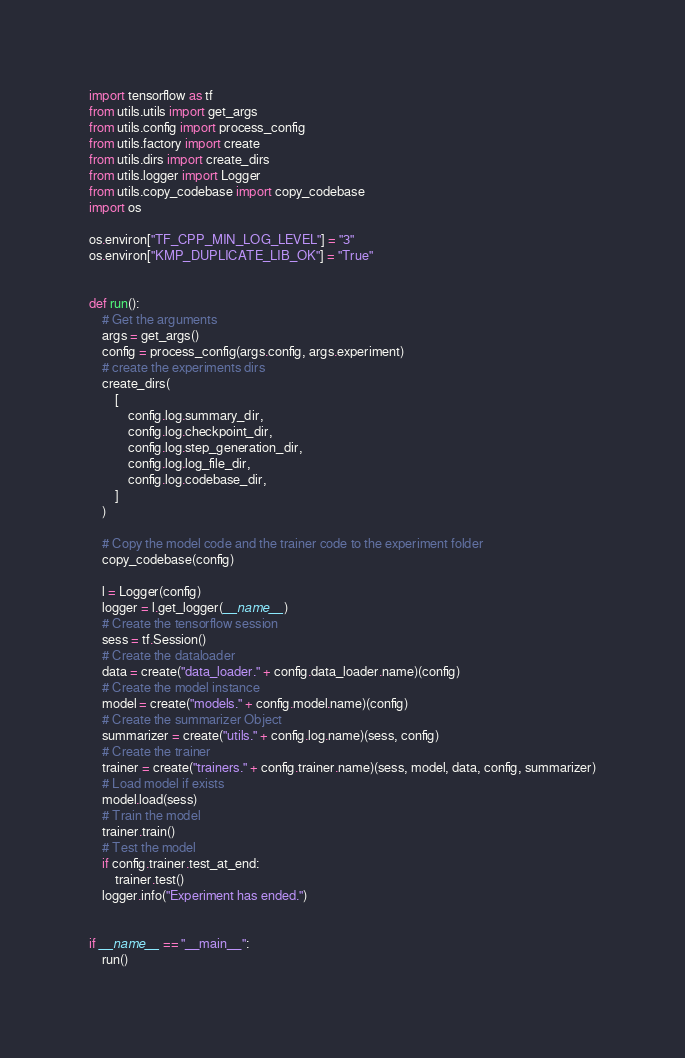<code> <loc_0><loc_0><loc_500><loc_500><_Python_>import tensorflow as tf
from utils.utils import get_args
from utils.config import process_config
from utils.factory import create
from utils.dirs import create_dirs
from utils.logger import Logger
from utils.copy_codebase import copy_codebase
import os

os.environ["TF_CPP_MIN_LOG_LEVEL"] = "3"
os.environ["KMP_DUPLICATE_LIB_OK"] = "True"


def run():
    # Get the arguments
    args = get_args()
    config = process_config(args.config, args.experiment)
    # create the experiments dirs
    create_dirs(
        [
            config.log.summary_dir,
            config.log.checkpoint_dir,
            config.log.step_generation_dir,
            config.log.log_file_dir,
            config.log.codebase_dir,
        ]
    )

    # Copy the model code and the trainer code to the experiment folder
    copy_codebase(config)

    l = Logger(config)
    logger = l.get_logger(__name__)
    # Create the tensorflow session
    sess = tf.Session()
    # Create the dataloader
    data = create("data_loader." + config.data_loader.name)(config)
    # Create the model instance
    model = create("models." + config.model.name)(config)
    # Create the summarizer Object
    summarizer = create("utils." + config.log.name)(sess, config)
    # Create the trainer
    trainer = create("trainers." + config.trainer.name)(sess, model, data, config, summarizer)
    # Load model if exists
    model.load(sess)
    # Train the model
    trainer.train()
    # Test the model
    if config.trainer.test_at_end:
        trainer.test()
    logger.info("Experiment has ended.")


if __name__ == "__main__":
    run()
</code> 